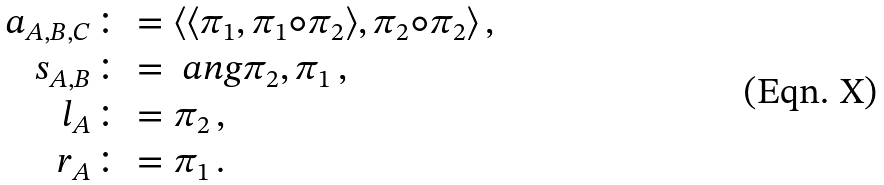<formula> <loc_0><loc_0><loc_500><loc_500>a _ { A , B , C } & \colon = \langle \langle \pi _ { 1 } , \pi _ { 1 } \circ \pi _ { 2 } \rangle , \pi _ { 2 } \circ \pi _ { 2 } \rangle \, , \\ s _ { A , B } & \colon = \ a n g { \pi _ { 2 } , \pi _ { 1 } } \, , \\ l _ { A } & \colon = \pi _ { 2 } \, , \\ r _ { A } & \colon = \pi _ { 1 } \, .</formula> 